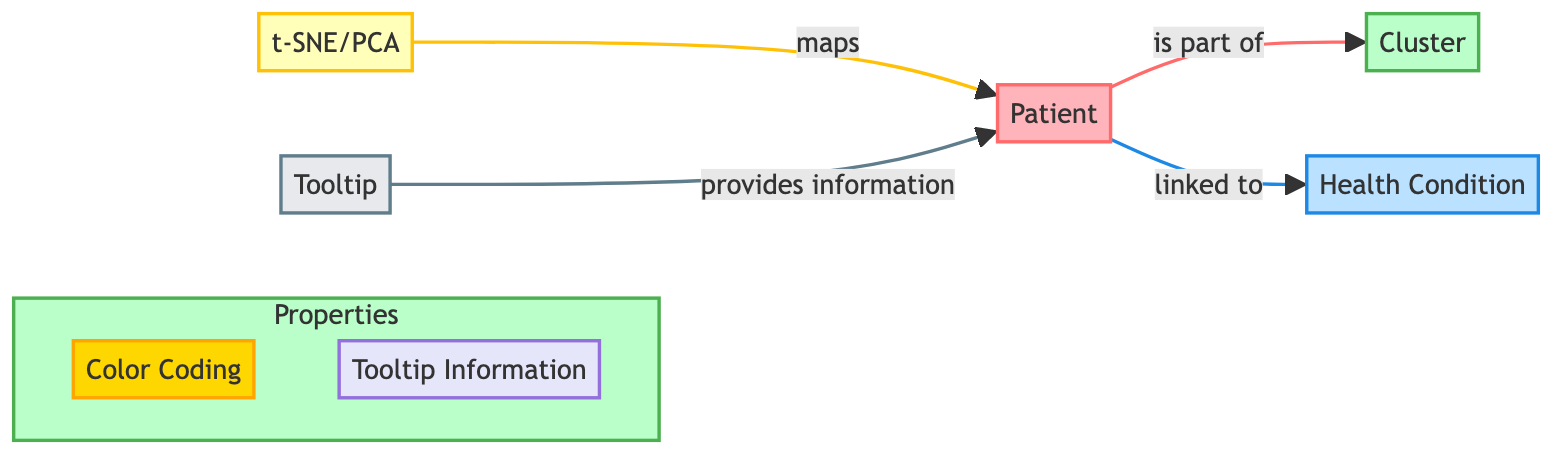What is the main technique used to reduce dimensions in this diagram? The diagram explicitly labels the dimension reduction technique used as t-SNE/PCA. This is indicated by the node that directly connects to the patient node, showing the path of understanding how patient data is processed.
Answer: t-SNE/PCA How many nodes are represented in the diagram? The diagram contains five distinct nodes: Patient, Cluster, Health Condition, t-SNE/PCA, and Tooltip. Each node represents a key component of the data representation.
Answer: Five What does the Cluster node represent in relation to Patient? The arrow from Patient to Cluster indicates that each patient is categorized into a cluster, suggesting that patients with similar profiles are grouped together. Therefore, the Cluster node represents a grouping of similar patient profiles.
Answer: Grouping of similar patient profiles What type of information does the Tooltip provide? The Tooltip node is connected to the Patient node with a labeled relationship that indicates it provides information related to patients. This suggests that the tooltip displays additional data on the patients when interacted with.
Answer: Additional patient data What colors represent the Health Condition in the diagram? The Health Condition node is color-coded in a light blue shade as shown in the diagram, indicating its association with health conditions linked to patients.
Answer: Light blue 